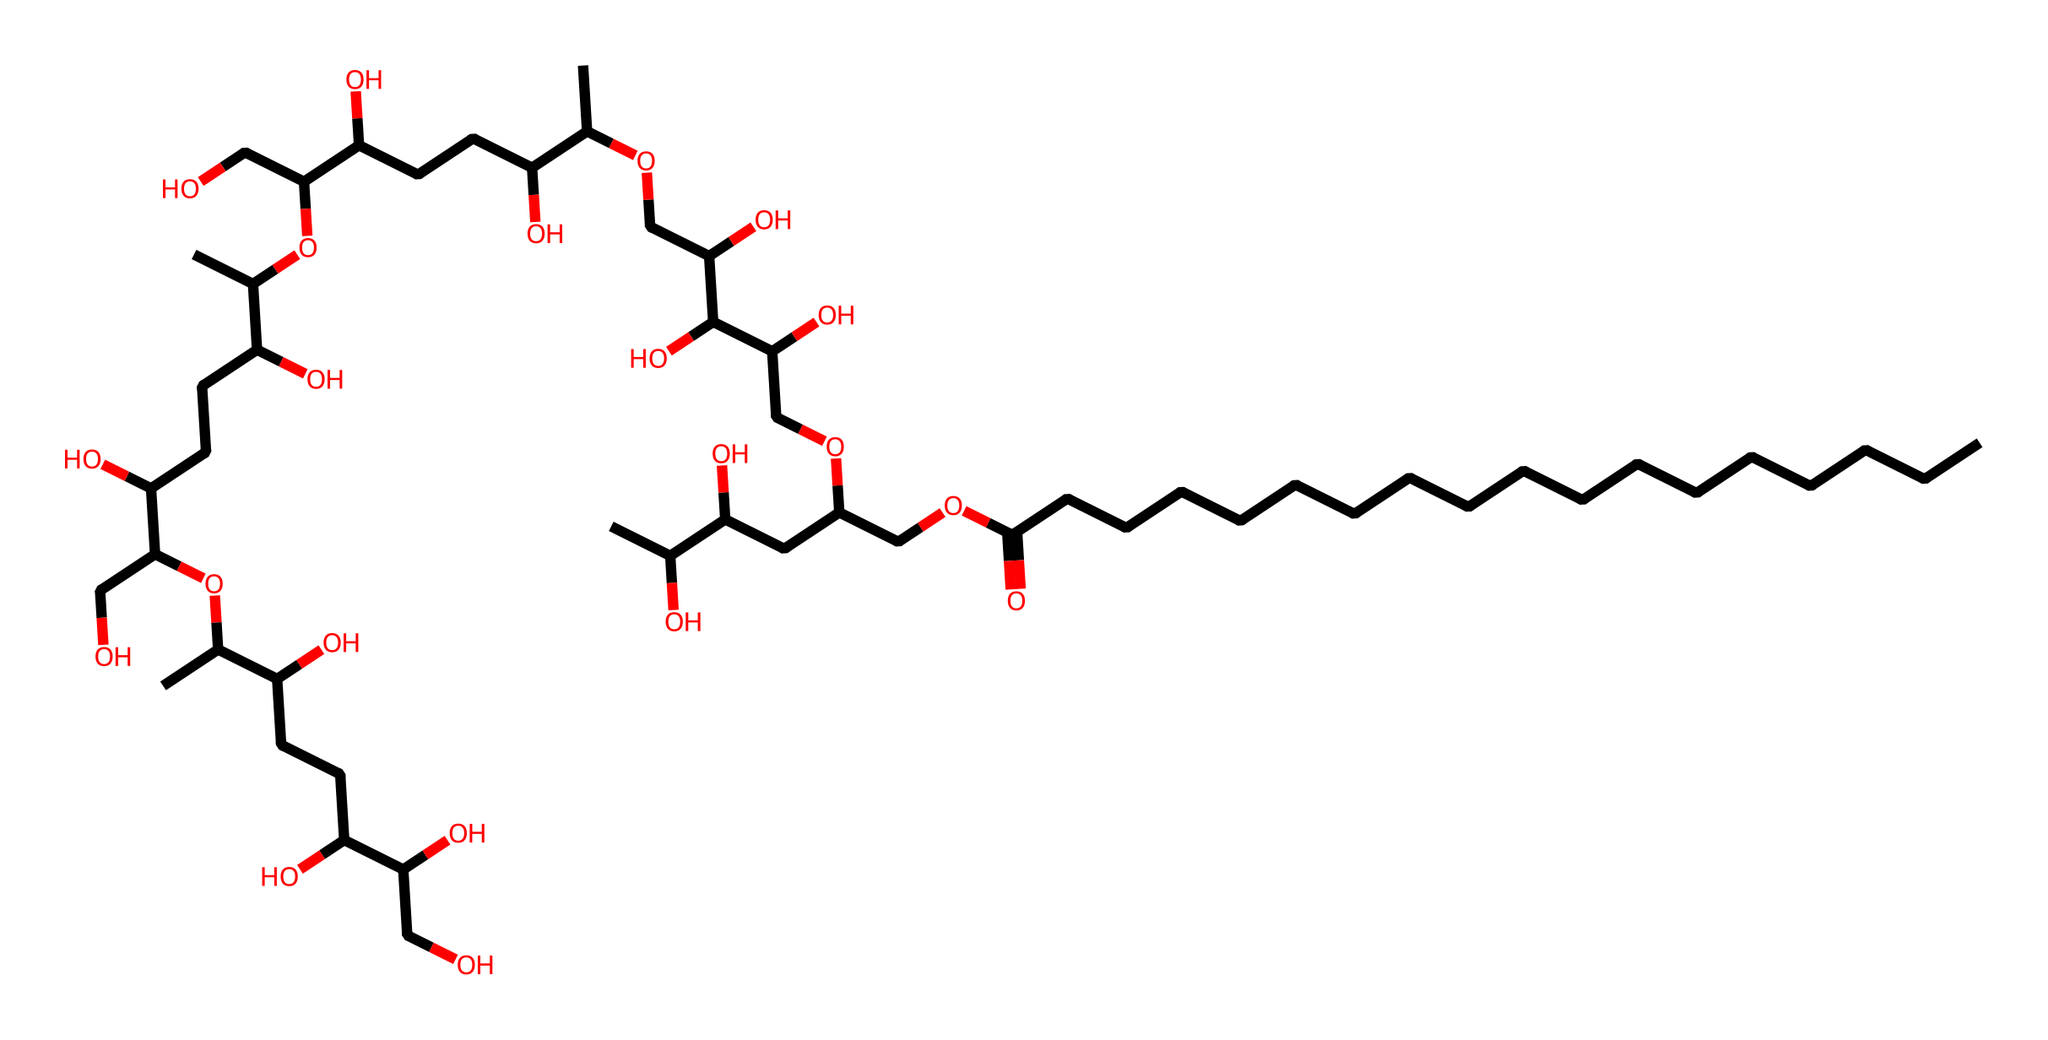What is the molecular formula of polysorbate 80? To determine the molecular formula, analyze the SMILES representation for distinct elements and their counts. The primary elements present are Carbon (C), Hydrogen (H), and Oxygen (O). By counting, we find there are 80 Carbon atoms, 158 Hydrogen atoms, and 20 Oxygen atoms.
Answer: C80H158O20 How many chiral centers are in polysorbate 80? Chiral centers occur at carbon atoms bonded to four different substituents. By examining the structure, we identify chiral carbon atoms in the region that contains alcohol groups. There are 7 such centers in total as indicated by the structural branching.
Answer: 7 What type of surfactant is polysorbate 80? Polysorbate 80 is classified based on its structure and the roles of its components. It has a hydrophilic polysorbate head due to the polyethyleneglycol moiety and a hydrophobic fatty acid tail, which means it’s a non-ionic surfactant.
Answer: non-ionic How many double bonds are present in the fatty acid chain? By assessing the SMILES representation, we primarily focus on the carbon chain connected to the C(=O)O group. There are no double bonds indicated in this chain; the structure is fully saturated.
Answer: 0 Identify the main functional groups in polysorbate 80. The presence of (-COOH), (-O-), and hydroxyl (-OH) groups indicate the functional groups in polysorbate 80. In the SMILES notation, these appear in repeating units throughout the structure, which are characteristic of surfactants, specifically in polysorbate.
Answer: carboxylic acid, ether, alcohol What is the role of polysorbate 80 in makeup removers? The chemical structure allows for dual affinity due to its amphiphilic nature, assisting in emulsifying both oil-based and water-based makeup products, promoting their removal during cleansing.
Answer: emulsifier How does the size of the hydrophobic tail affect its surfactant properties? A larger hydrophobic tail enhances the surfactant's ability to solubilize and emulsify oils due to increased interaction with oil molecules. In polysorbate 80, the extensive carbon chain supports these properties.
Answer: improves solubilization 